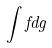<formula> <loc_0><loc_0><loc_500><loc_500>\int f d g</formula> 